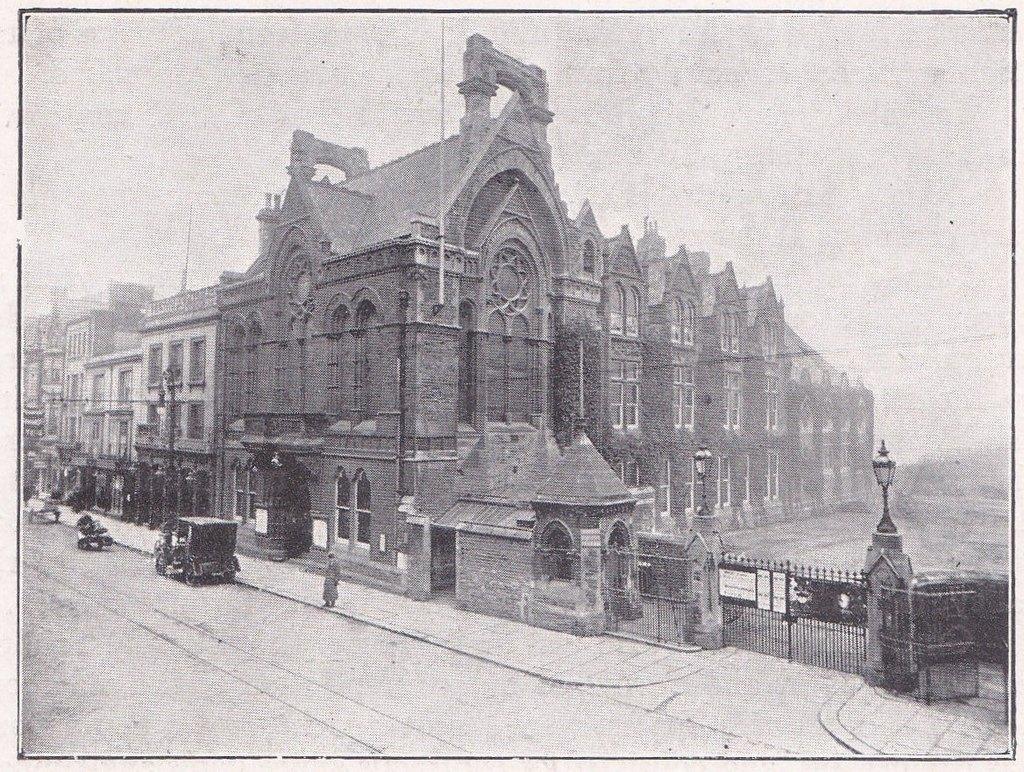Can you describe this image briefly? In the picture I can see buildings, fence, gates, vehicles on the road and some other objects. In the background I can see the sky. This picture is black and white in color. 